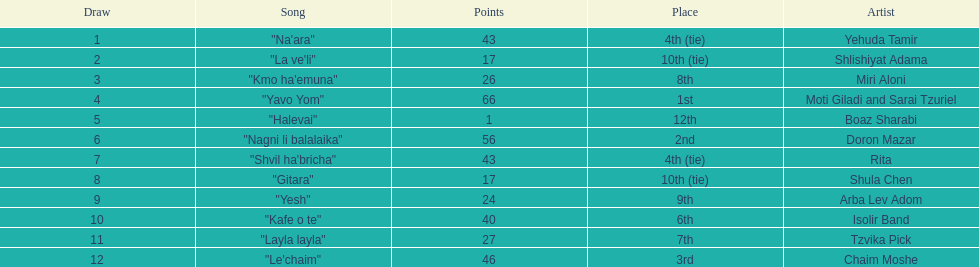Doron mazar, which artist(s) had the most points? Moti Giladi and Sarai Tzuriel. Could you parse the entire table? {'header': ['Draw', 'Song', 'Points', 'Place', 'Artist'], 'rows': [['1', '"Na\'ara"', '43', '4th (tie)', 'Yehuda Tamir'], ['2', '"La ve\'li"', '17', '10th (tie)', 'Shlishiyat Adama'], ['3', '"Kmo ha\'emuna"', '26', '8th', 'Miri Aloni'], ['4', '"Yavo Yom"', '66', '1st', 'Moti Giladi and Sarai Tzuriel'], ['5', '"Halevai"', '1', '12th', 'Boaz Sharabi'], ['6', '"Nagni li balalaika"', '56', '2nd', 'Doron Mazar'], ['7', '"Shvil ha\'bricha"', '43', '4th (tie)', 'Rita'], ['8', '"Gitara"', '17', '10th (tie)', 'Shula Chen'], ['9', '"Yesh"', '24', '9th', 'Arba Lev Adom'], ['10', '"Kafe o te"', '40', '6th', 'Isolir Band'], ['11', '"Layla layla"', '27', '7th', 'Tzvika Pick'], ['12', '"Le\'chaim"', '46', '3rd', 'Chaim Moshe']]} 